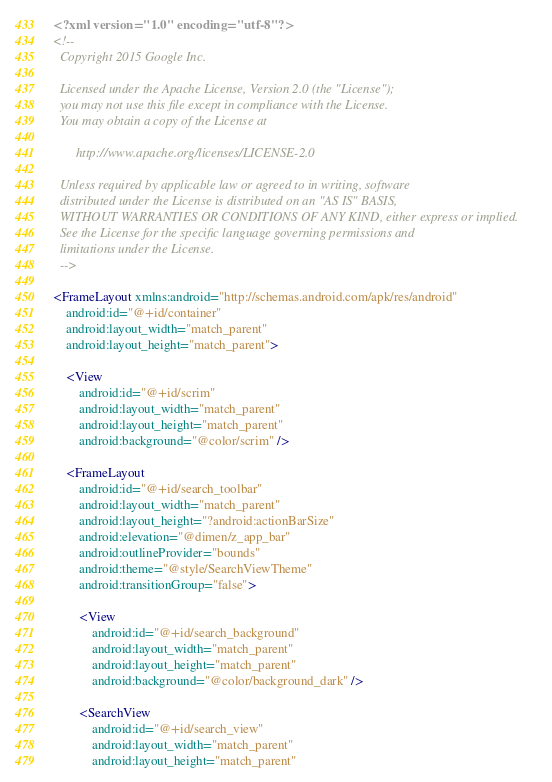<code> <loc_0><loc_0><loc_500><loc_500><_XML_><?xml version="1.0" encoding="utf-8"?>
<!--
  Copyright 2015 Google Inc.

  Licensed under the Apache License, Version 2.0 (the "License");
  you may not use this file except in compliance with the License.
  You may obtain a copy of the License at

       http://www.apache.org/licenses/LICENSE-2.0

  Unless required by applicable law or agreed to in writing, software
  distributed under the License is distributed on an "AS IS" BASIS,
  WITHOUT WARRANTIES OR CONDITIONS OF ANY KIND, either express or implied.
  See the License for the specific language governing permissions and
  limitations under the License.
  -->

<FrameLayout xmlns:android="http://schemas.android.com/apk/res/android"
    android:id="@+id/container"
    android:layout_width="match_parent"
    android:layout_height="match_parent">

    <View
        android:id="@+id/scrim"
        android:layout_width="match_parent"
        android:layout_height="match_parent"
        android:background="@color/scrim" />

    <FrameLayout
        android:id="@+id/search_toolbar"
        android:layout_width="match_parent"
        android:layout_height="?android:actionBarSize"
        android:elevation="@dimen/z_app_bar"
        android:outlineProvider="bounds"
        android:theme="@style/SearchViewTheme"
        android:transitionGroup="false">

        <View
            android:id="@+id/search_background"
            android:layout_width="match_parent"
            android:layout_height="match_parent"
            android:background="@color/background_dark" />

        <SearchView
            android:id="@+id/search_view"
            android:layout_width="match_parent"
            android:layout_height="match_parent"</code> 